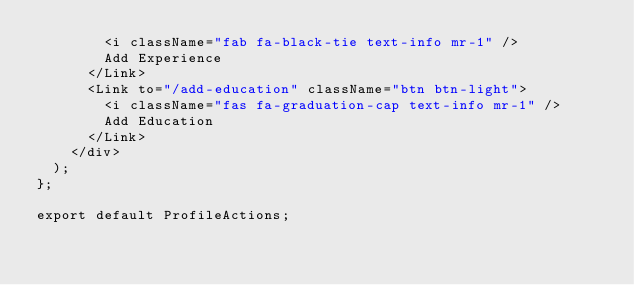Convert code to text. <code><loc_0><loc_0><loc_500><loc_500><_JavaScript_>        <i className="fab fa-black-tie text-info mr-1" />
        Add Experience
      </Link>
      <Link to="/add-education" className="btn btn-light">
        <i className="fas fa-graduation-cap text-info mr-1" />
        Add Education
      </Link>
    </div>
  );
};

export default ProfileActions;
</code> 